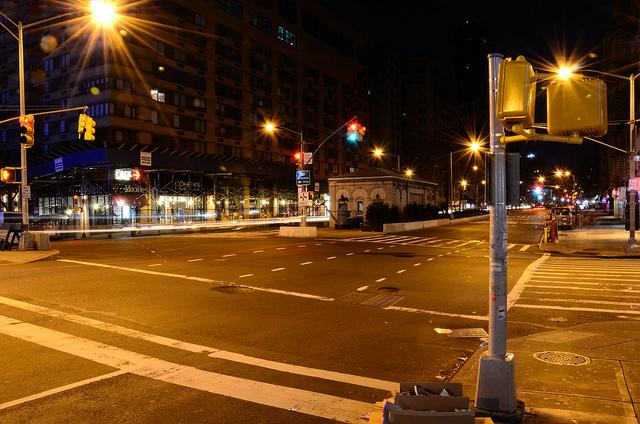How is the street staying illuminated? lights 